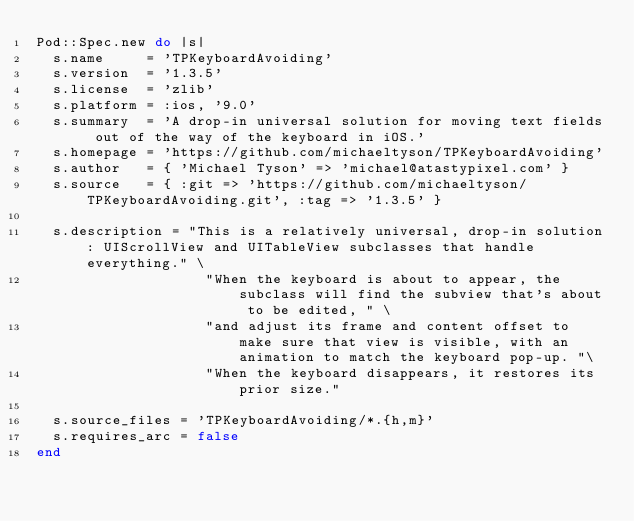<code> <loc_0><loc_0><loc_500><loc_500><_Ruby_>Pod::Spec.new do |s|
  s.name     = 'TPKeyboardAvoiding'
  s.version  = '1.3.5'
  s.license  = 'zlib'
  s.platform = :ios, '9.0'
  s.summary  = 'A drop-in universal solution for moving text fields out of the way of the keyboard in iOS.'
  s.homepage = 'https://github.com/michaeltyson/TPKeyboardAvoiding'
  s.author   = { 'Michael Tyson' => 'michael@atastypixel.com' }
  s.source   = { :git => 'https://github.com/michaeltyson/TPKeyboardAvoiding.git', :tag => '1.3.5' }

  s.description = "This is a relatively universal, drop-in solution: UIScrollView and UITableView subclasses that handle everything." \
                    "When the keyboard is about to appear, the subclass will find the subview that's about to be edited, " \
                    "and adjust its frame and content offset to make sure that view is visible, with an animation to match the keyboard pop-up. "\
                    "When the keyboard disappears, it restores its prior size." 

  s.source_files = 'TPKeyboardAvoiding/*.{h,m}'
  s.requires_arc = false
end
</code> 